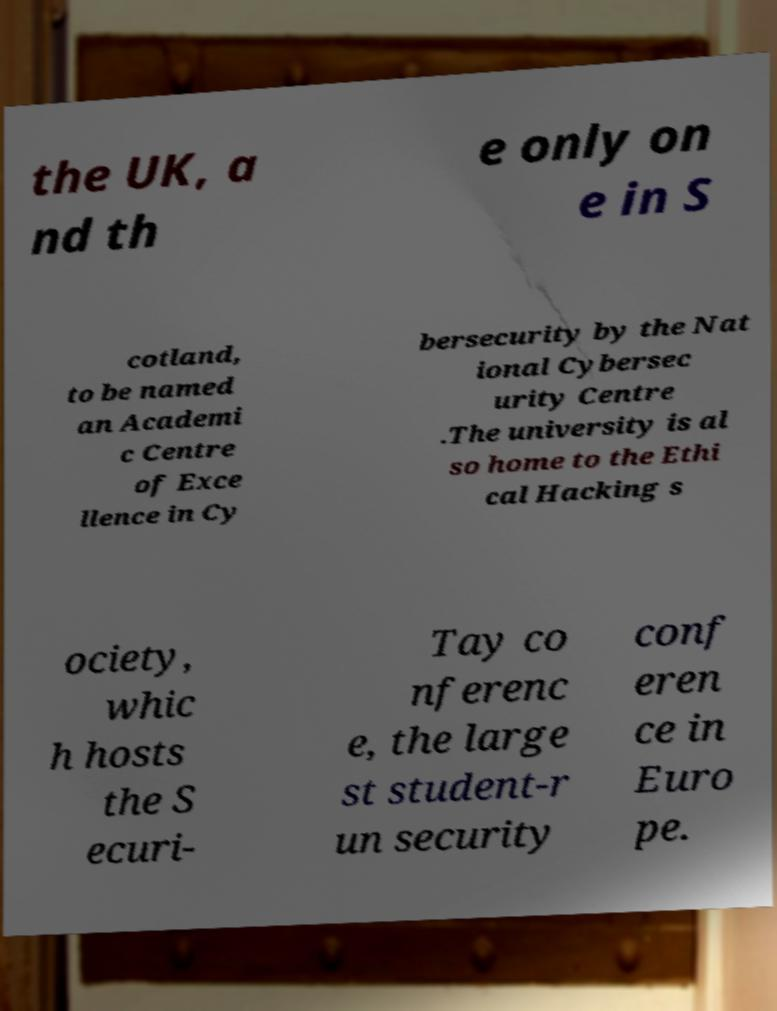There's text embedded in this image that I need extracted. Can you transcribe it verbatim? the UK, a nd th e only on e in S cotland, to be named an Academi c Centre of Exce llence in Cy bersecurity by the Nat ional Cybersec urity Centre .The university is al so home to the Ethi cal Hacking s ociety, whic h hosts the S ecuri- Tay co nferenc e, the large st student-r un security conf eren ce in Euro pe. 